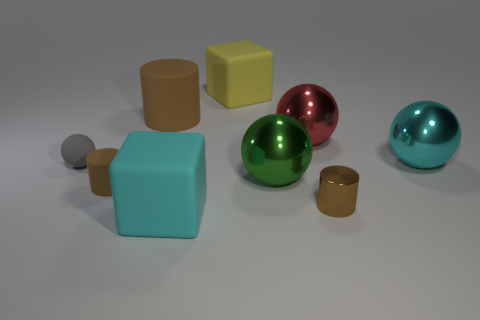How many brown cylinders must be subtracted to get 1 brown cylinders? 2 Subtract all red spheres. How many spheres are left? 3 Subtract all large green metallic spheres. How many spheres are left? 3 Add 1 green shiny things. How many objects exist? 10 Subtract 1 cylinders. How many cylinders are left? 2 Subtract all yellow spheres. Subtract all green blocks. How many spheres are left? 4 Subtract all cylinders. How many objects are left? 6 Subtract all tiny purple rubber cylinders. Subtract all cylinders. How many objects are left? 6 Add 7 large red metal spheres. How many large red metal spheres are left? 8 Add 9 yellow spheres. How many yellow spheres exist? 9 